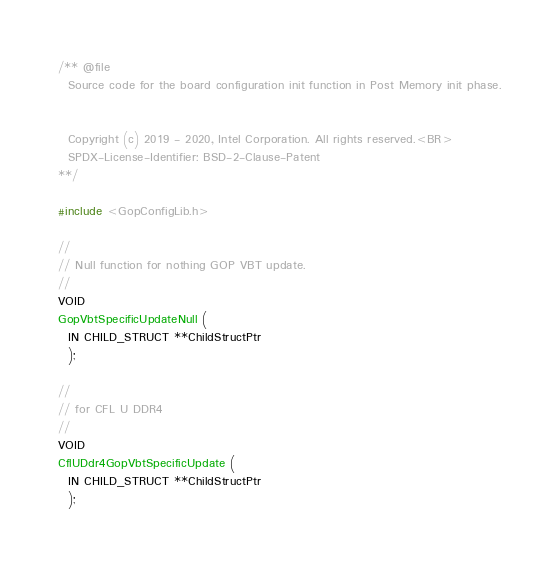Convert code to text. <code><loc_0><loc_0><loc_500><loc_500><_C_>/** @file
  Source code for the board configuration init function in Post Memory init phase.


  Copyright (c) 2019 - 2020, Intel Corporation. All rights reserved.<BR>
  SPDX-License-Identifier: BSD-2-Clause-Patent
**/

#include <GopConfigLib.h>

//
// Null function for nothing GOP VBT update.
//
VOID
GopVbtSpecificUpdateNull (
  IN CHILD_STRUCT **ChildStructPtr
  );

//
// for CFL U DDR4
//
VOID
CflUDdr4GopVbtSpecificUpdate (
  IN CHILD_STRUCT **ChildStructPtr
  );
</code> 